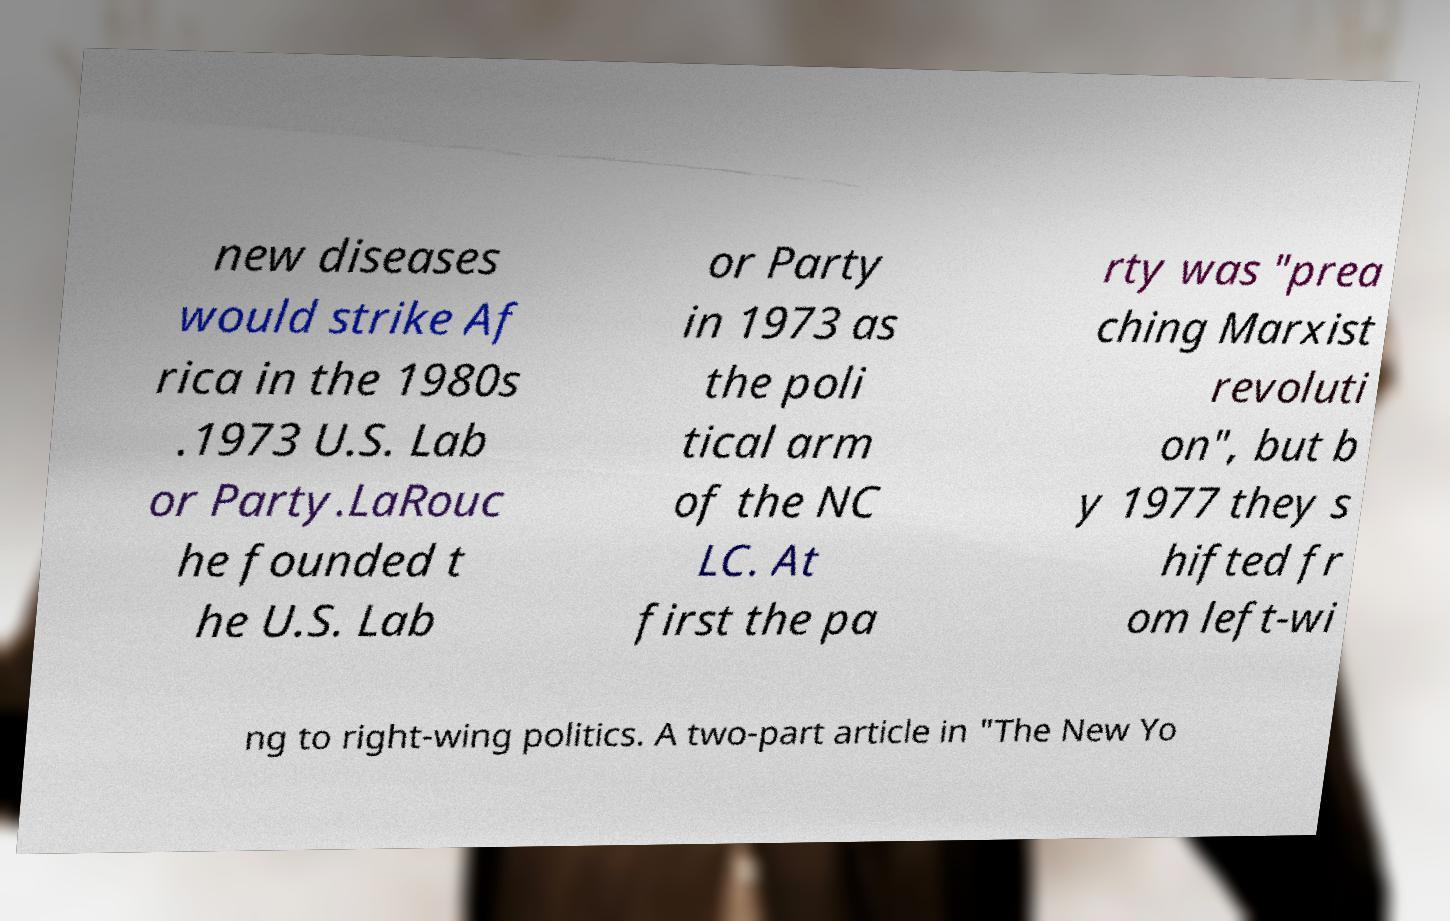There's text embedded in this image that I need extracted. Can you transcribe it verbatim? new diseases would strike Af rica in the 1980s .1973 U.S. Lab or Party.LaRouc he founded t he U.S. Lab or Party in 1973 as the poli tical arm of the NC LC. At first the pa rty was "prea ching Marxist revoluti on", but b y 1977 they s hifted fr om left-wi ng to right-wing politics. A two-part article in "The New Yo 